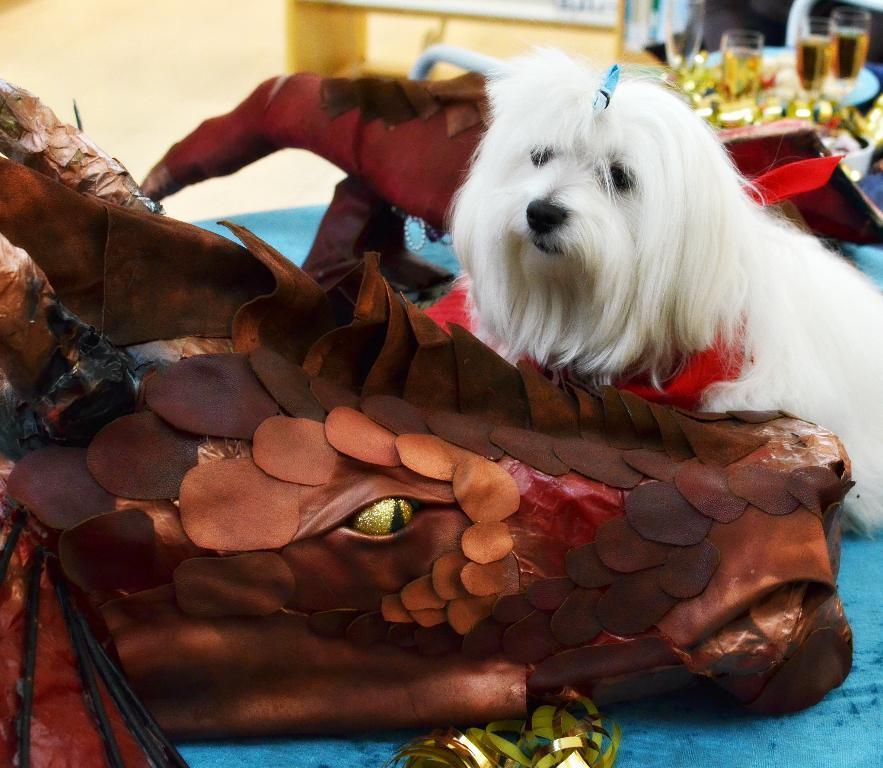Describe this image in one or two sentences. In this image there is an animal face made with some decorative items , a white color dog on the table, and in the background there are glasses with some liquids in it on the table. 